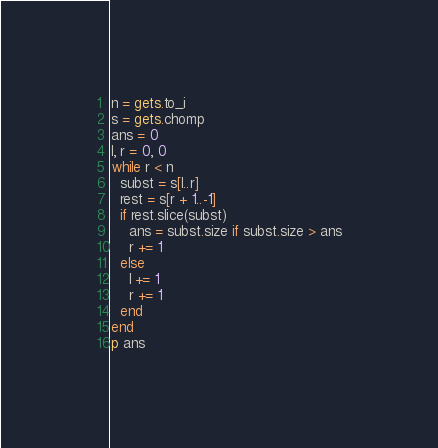Convert code to text. <code><loc_0><loc_0><loc_500><loc_500><_Ruby_>n = gets.to_i
s = gets.chomp
ans = 0
l, r = 0, 0
while r < n
  subst = s[l..r]
  rest = s[r + 1..-1]
  if rest.slice(subst)
    ans = subst.size if subst.size > ans
    r += 1
  else
    l += 1
    r += 1
  end
end
p ans
</code> 